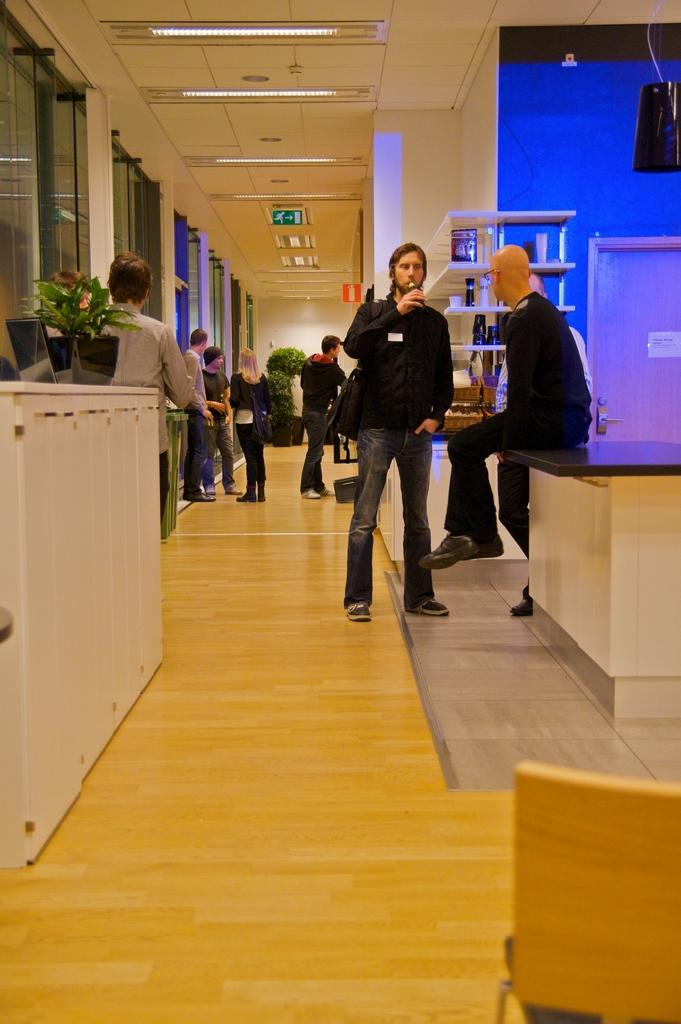What type of furniture is present in the image? There is a chair and a table in the image. What can be seen on the walls in the image? There are lights and a screen in the image. What type of object is present on the table? There is a pot on the table in the image. What electronic device is visible in the image? There is a laptop in the image. Are there any living organisms present in the image? Yes, there are people in the image. How many rabbits are playing a game on the form in the image? There are no rabbits, game, or form present in the image. 